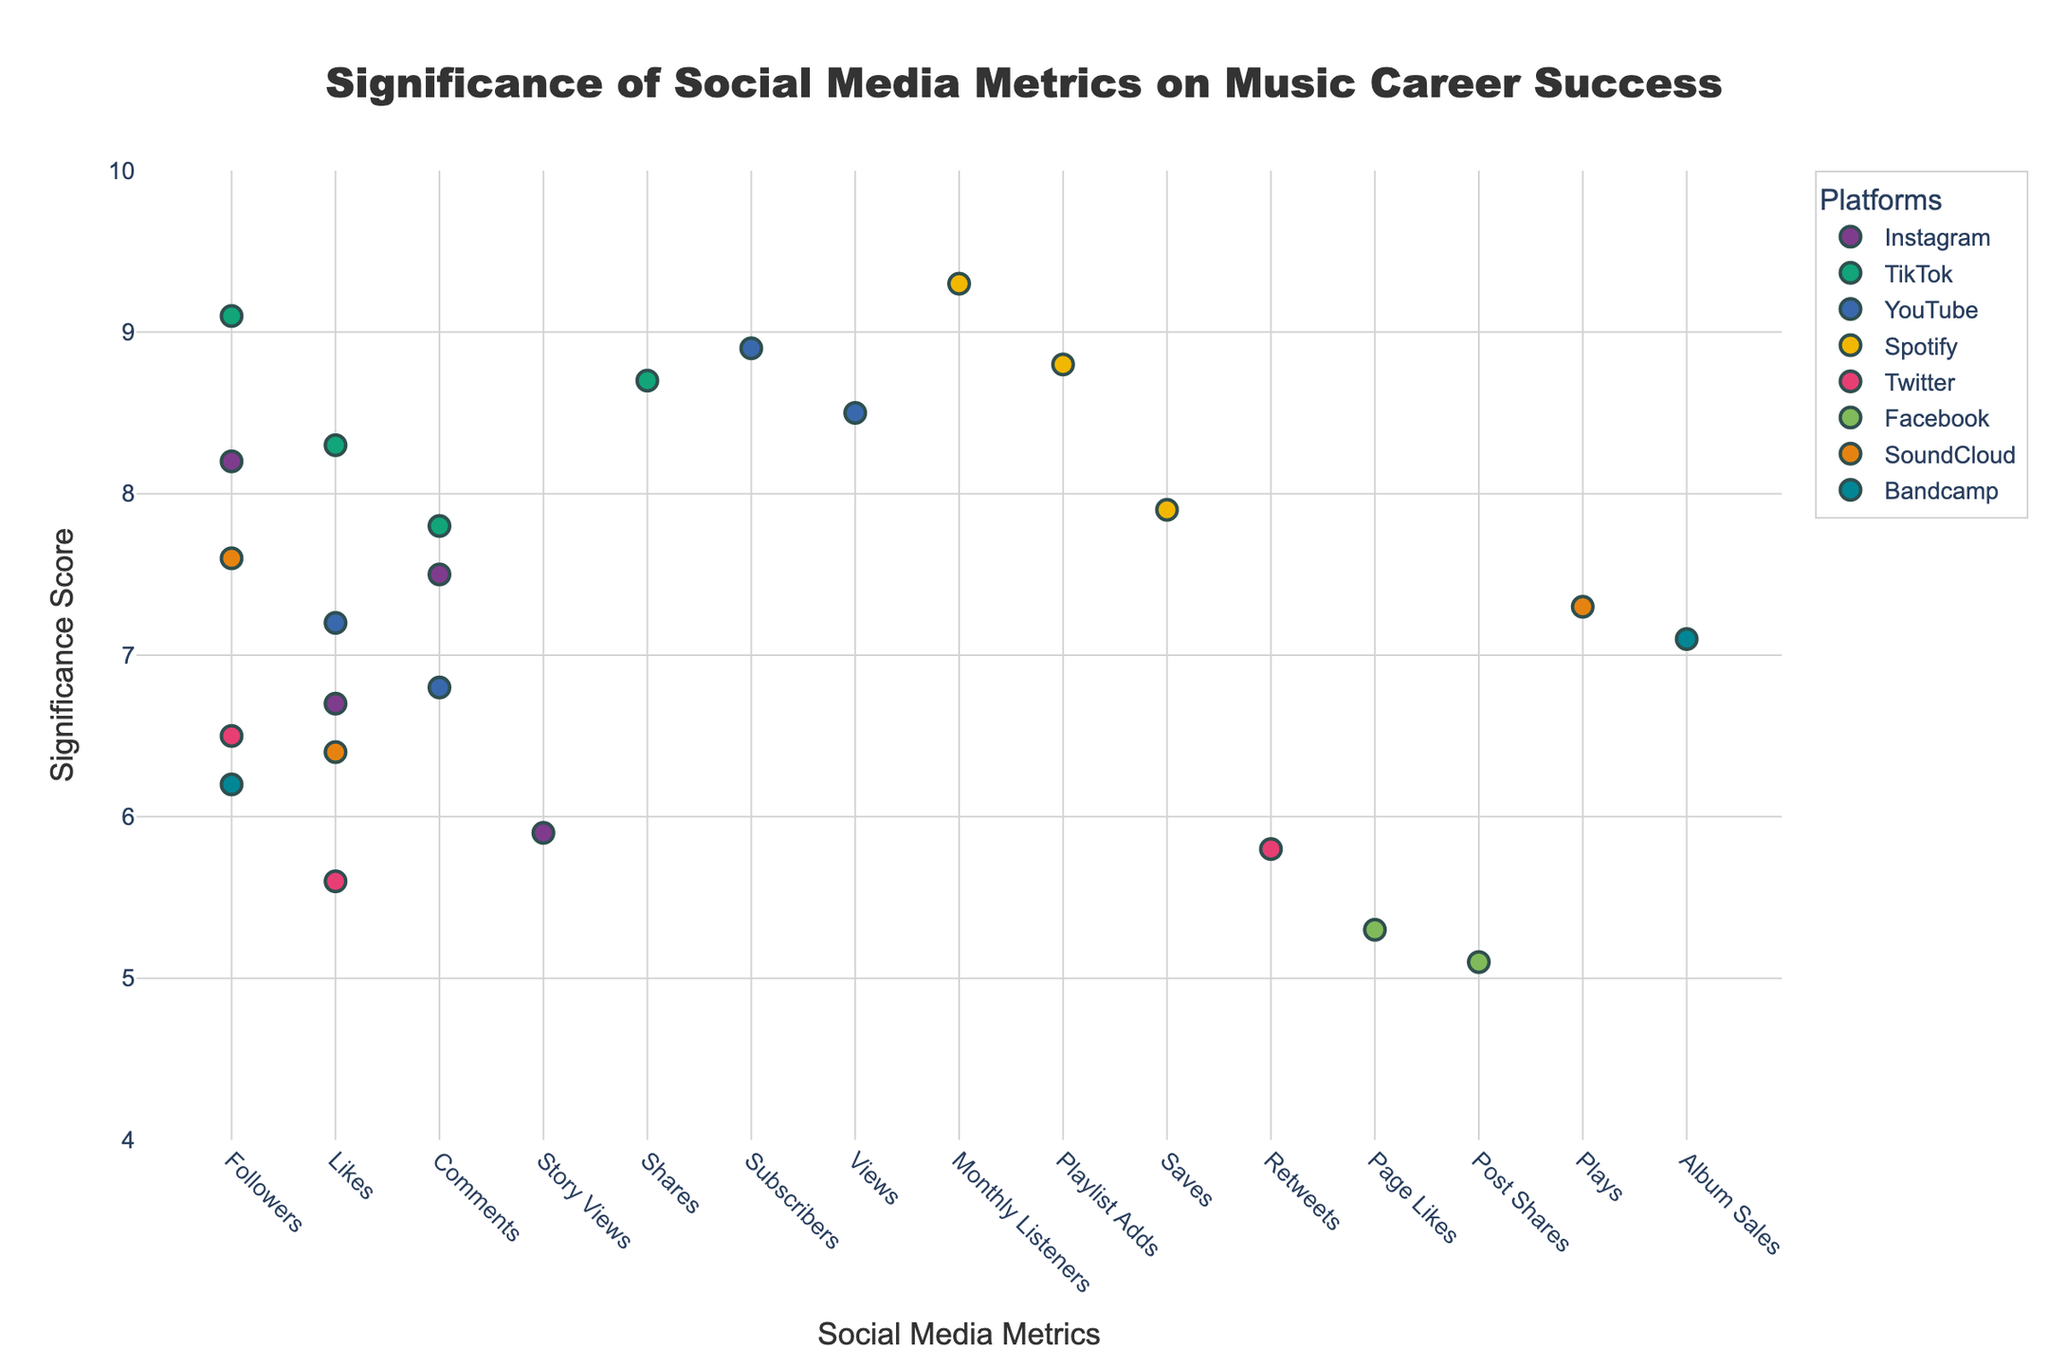What social media platform has the highest significance metric? By looking at the y-axis, we identify the highest point on the plot and note which platform it corresponds to.
Answer: Spotify What is the significance score for TikTok Shares? Find the point labeled "Shares" under the TikTok platform on the x-axis and note the corresponding y-axis value.
Answer: 8.7 Which social media metric has the lowest significance score? Locate the point with the lowest y-axis value across all the plots and identify its corresponding metric on the x-axis.
Answer: Facebook Post Shares How does the significance of Instagram Followers compare to TikTok Followers? Compare the y-axis values for the points labeled "Followers" for Instagram and TikTok.
Answer: TikTok Followers are more significant than Instagram Followers What is the average significance score of all metrics from YouTube? Sum the significance scores for YouTube metrics and divide by the number of metrics: (8.9 + 8.5 + 7.2 + 6.8) / 4.
Answer: 7.85 Which platform has the most metrics with a significance score greater than 8? Count the number of metrics for each platform that have a score above 8.
Answer: TikTok Compare the significance of SoundCloud Followers and SoundCloud Plays. Check the y-axis values for "Followers" and "Plays" under SoundCloud.
Answer: Followers have a higher significance score than Plays What is the difference in significance between Twitter Retweets and Facebook Page Likes? Subtract the significance score of Facebook Page Likes from Twitter Retweets: 5.8 - 5.3.
Answer: 0.5 How many metrics have a significance score above 7.5 on Instagram? Count the number of points for Instagram with a y-axis value above 7.5.
Answer: 2 